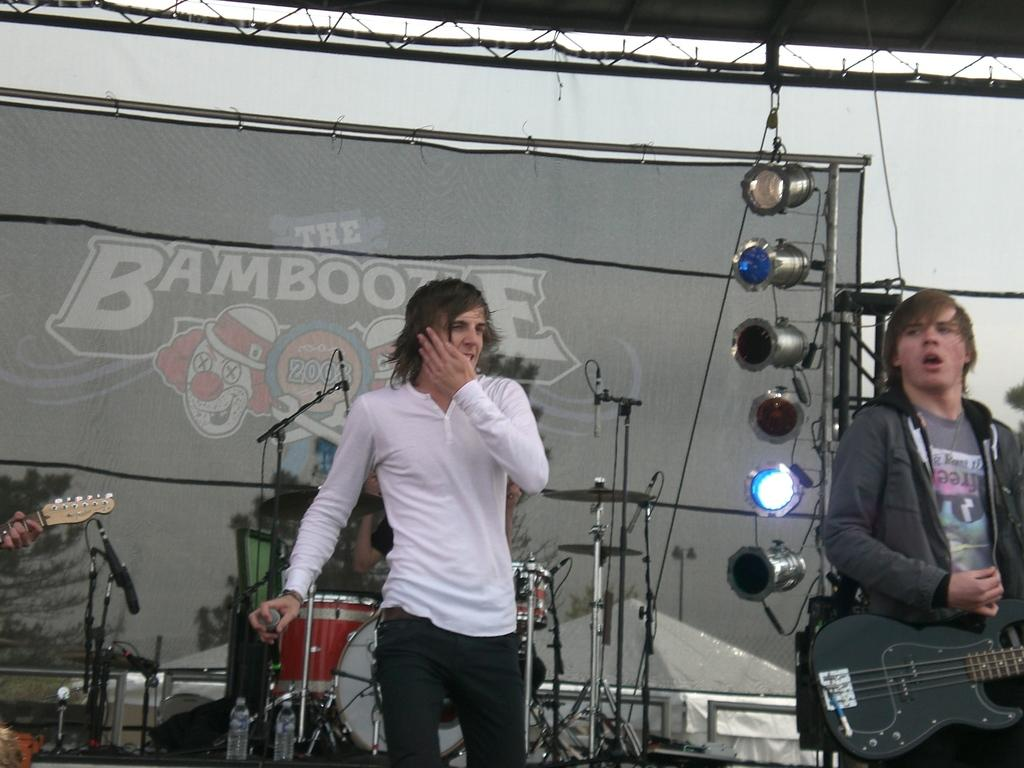What is the man in the white t-shirt doing in the image? The man in the white t-shirt is holding a mic in the image. What is the other man wearing and doing in the image? The man in a jacket is playing a guitar in the image. What can be seen in the image that might be used for lighting purposes? There are focusing lights in the image. What is present in the image that indicates the event or location? There is a banner in the image. What other objects are visible in the image related to the activity? There are musical instruments in the image. How many cows are present in the image? There are no cows present in the image. What type of hydrant is being used by the man in the white t-shirt? There is no hydrant present in the image. 